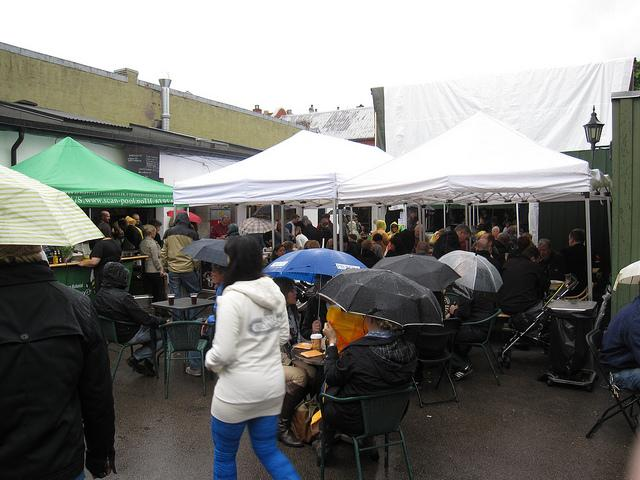Why is the outdoor area using covered gazebos? raining 